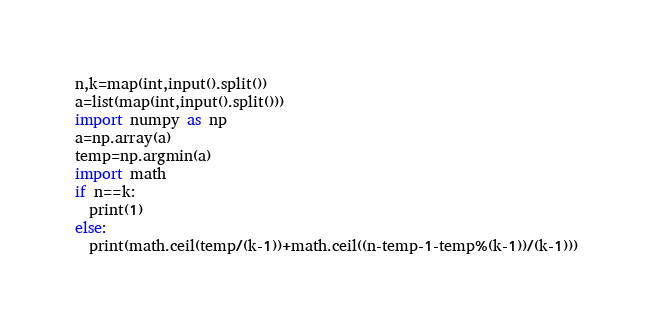<code> <loc_0><loc_0><loc_500><loc_500><_Python_>n,k=map(int,input().split())
a=list(map(int,input().split()))
import numpy as np
a=np.array(a)
temp=np.argmin(a)
import math
if n==k:
  print(1)
else:
  print(math.ceil(temp/(k-1))+math.ceil((n-temp-1-temp%(k-1))/(k-1)))
</code> 